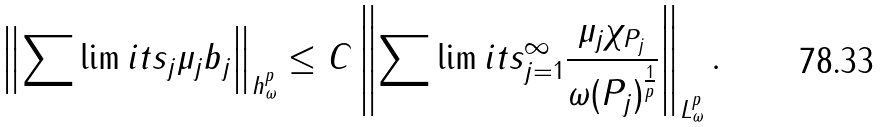<formula> <loc_0><loc_0><loc_500><loc_500>\left \| \sum \lim i t s _ { j } \mu _ { j } b _ { j } \right \| _ { h _ { \omega } ^ { p } } \leq C \left \| \sum \lim i t s _ { j = 1 } ^ { \infty } \frac { \mu _ { j } \chi _ { P _ { j } } } { \omega ( P _ { j } ) ^ { \frac { 1 } { p } } } \right \| _ { L _ { \omega } ^ { p } } .</formula> 